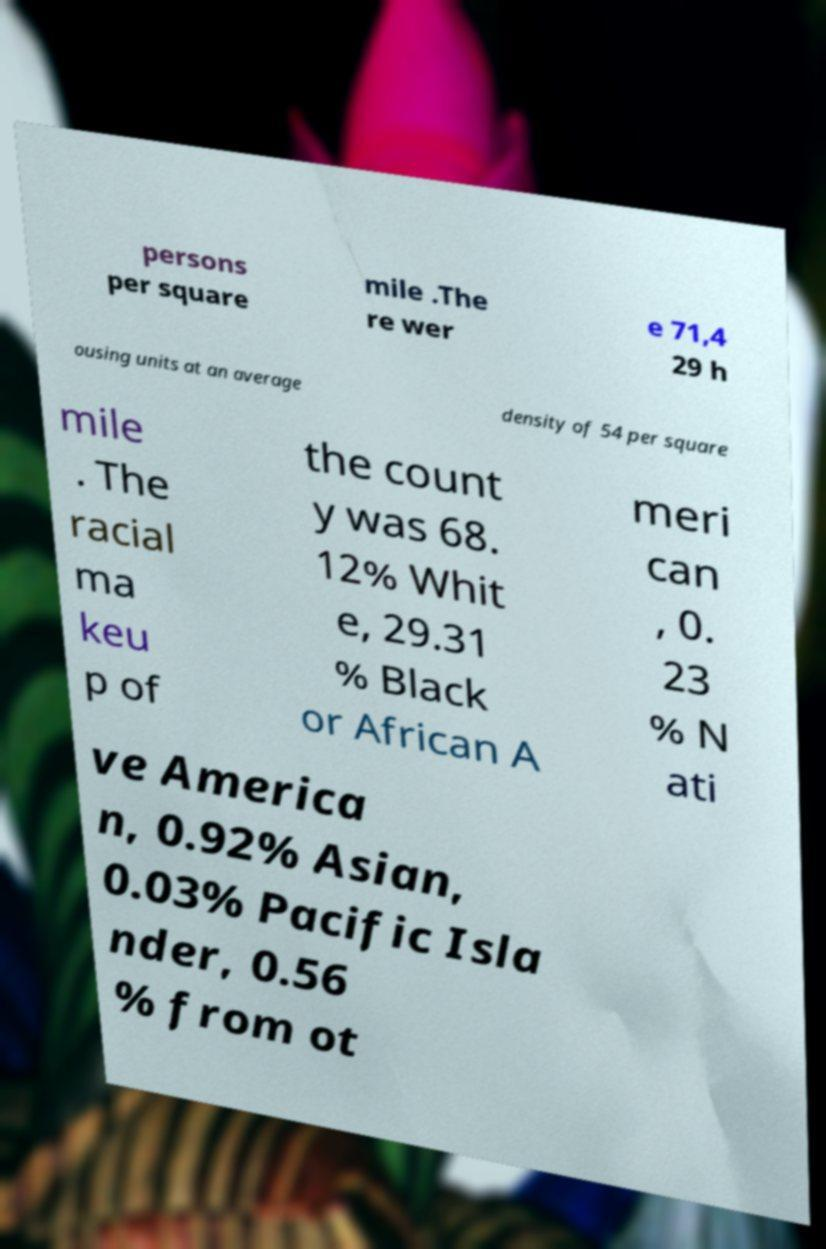Please read and relay the text visible in this image. What does it say? persons per square mile .The re wer e 71,4 29 h ousing units at an average density of 54 per square mile . The racial ma keu p of the count y was 68. 12% Whit e, 29.31 % Black or African A meri can , 0. 23 % N ati ve America n, 0.92% Asian, 0.03% Pacific Isla nder, 0.56 % from ot 